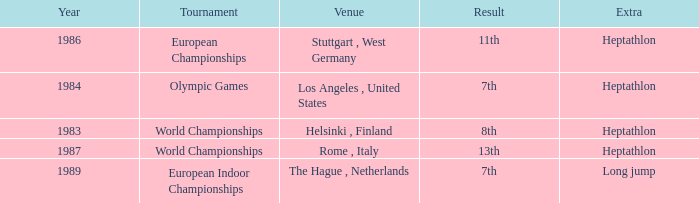Where was the 1984 Olympics hosted? Olympic Games. 